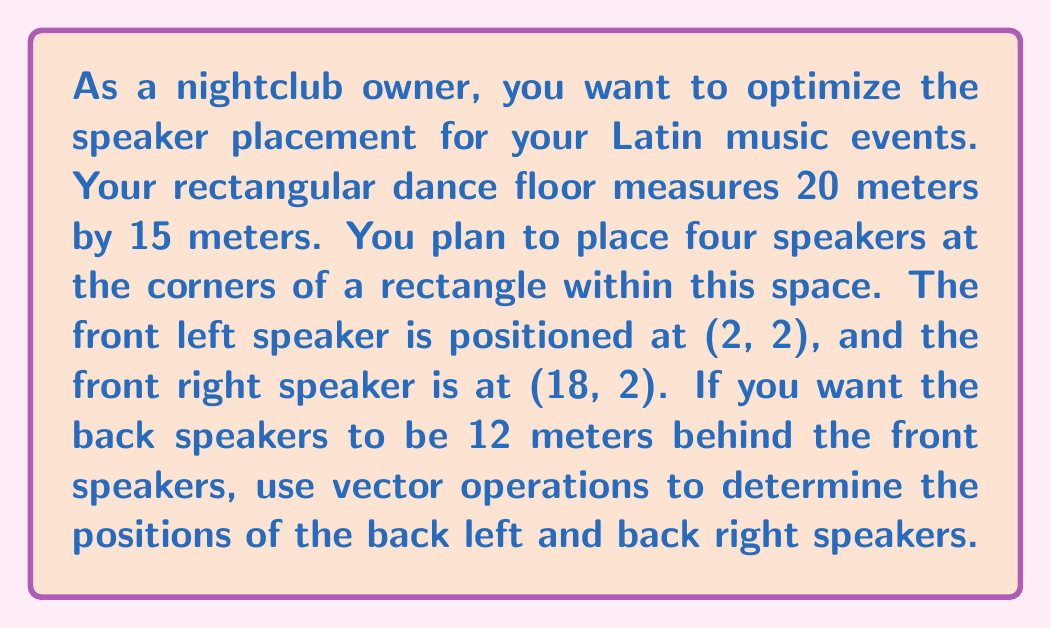What is the answer to this math problem? Let's approach this step-by-step using vector operations:

1) First, let's define our vectors. The vector from the front left to front right speaker is:
   $$\vec{v} = (18 - 2, 2 - 2) = (16, 0)$$

2) We need to find a vector perpendicular to this that points towards the back of the club. We can rotate $\vec{v}$ by 90 degrees clockwise:
   $$\vec{u} = (0, -16)$$

3) We want the back speakers to be 12 meters behind the front ones. So we need to scale $\vec{u}$ to have a magnitude of 12:
   $$\|\vec{u}\| = \sqrt{0^2 + (-16)^2} = 16$$
   
   Scaling factor: $\frac{12}{16} = \frac{3}{4}$
   
   $$\vec{w} = \frac{3}{4}\vec{u} = (0, -12)$$

4) Now, we can find the positions of the back speakers by adding $\vec{w}$ to the positions of the front speakers:

   Back Left: $(2, 2) + (0, -12) = (2, -10)$
   Back Right: $(18, 2) + (0, -12) = (18, -10)$

5) However, these y-coordinates are negative and outside our 15-meter width. We need to shift everything up by 12 meters:

   Front Left: $(2, 14)$
   Front Right: $(18, 14)$
   Back Left: $(2, 2)$
   Back Right: $(18, 2)$

This configuration maintains the 12-meter depth while keeping all speakers within the 20x15 meter dance floor.
Answer: The optimal speaker positions are:
Front Left: (2, 14)
Front Right: (18, 14)
Back Left: (2, 2)
Back Right: (18, 2) 